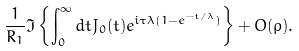<formula> <loc_0><loc_0><loc_500><loc_500>\frac { 1 } { R _ { 1 } } \Im \left \{ \int _ { 0 } ^ { \infty } d t J _ { 0 } ( t ) e ^ { i \tau \lambda ( 1 - e ^ { - t / \lambda } ) } \right \} + O ( \rho ) .</formula> 